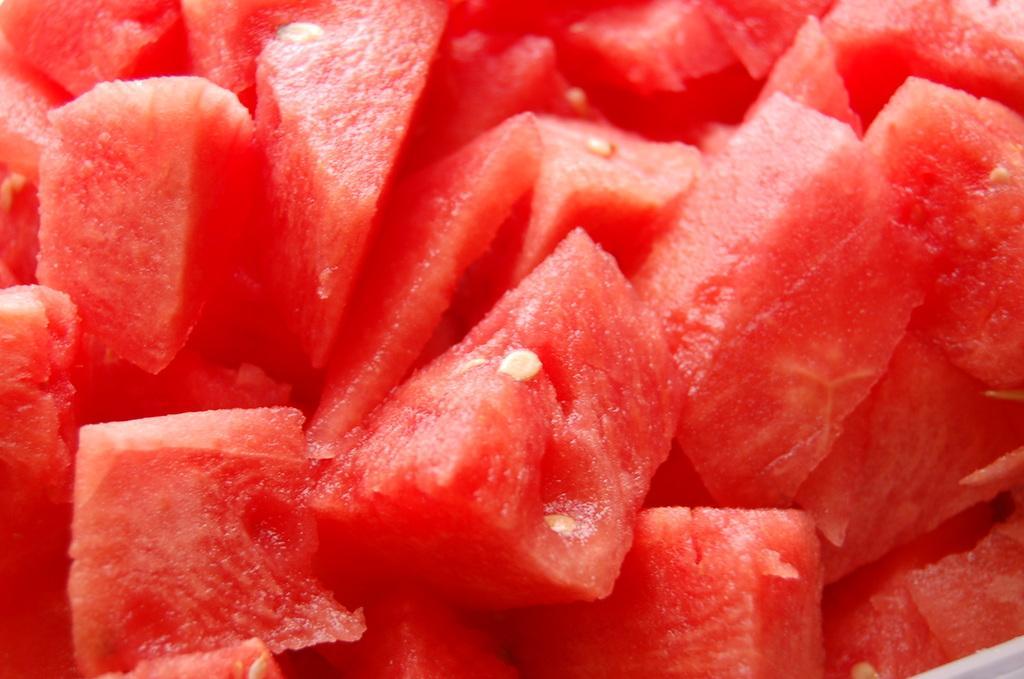Could you give a brief overview of what you see in this image? In this image there are a few watermelon slices. 